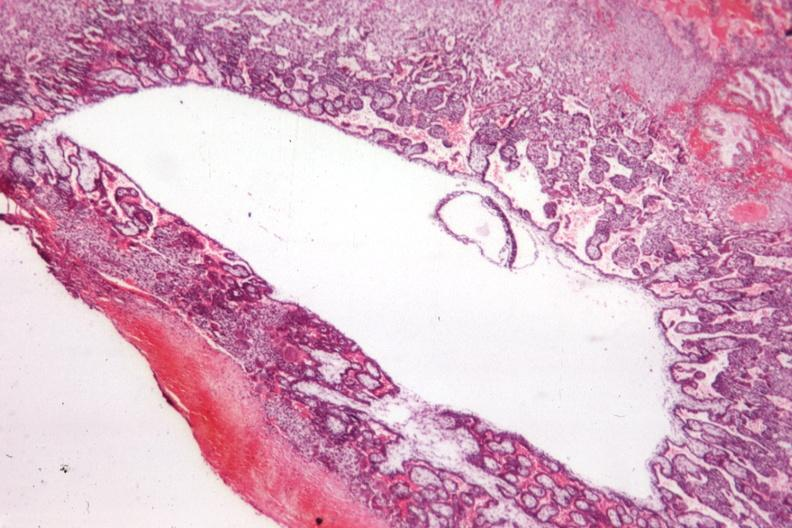what is present?
Answer the question using a single word or phrase. Fetus developing very early 